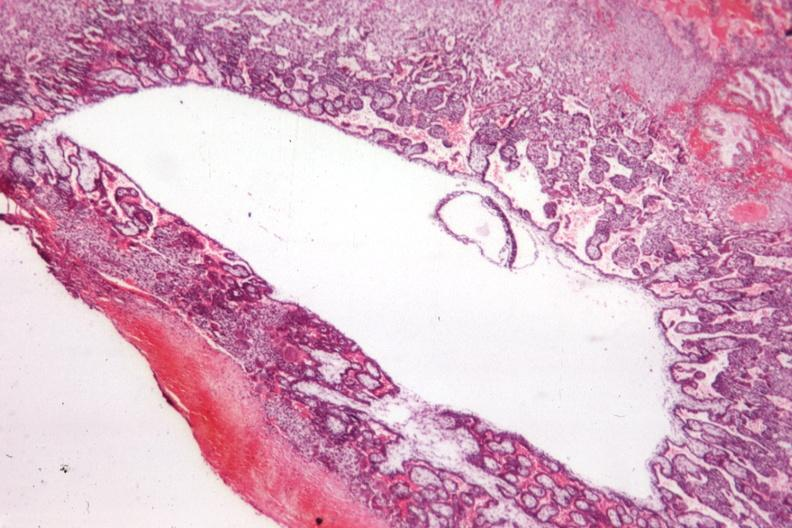what is present?
Answer the question using a single word or phrase. Fetus developing very early 